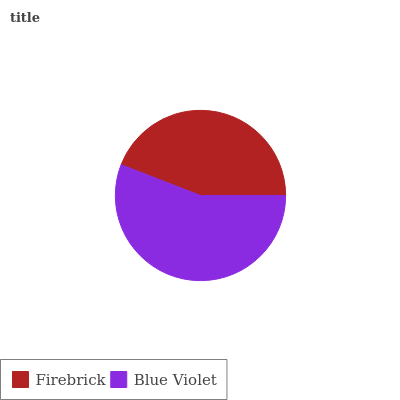Is Firebrick the minimum?
Answer yes or no. Yes. Is Blue Violet the maximum?
Answer yes or no. Yes. Is Blue Violet the minimum?
Answer yes or no. No. Is Blue Violet greater than Firebrick?
Answer yes or no. Yes. Is Firebrick less than Blue Violet?
Answer yes or no. Yes. Is Firebrick greater than Blue Violet?
Answer yes or no. No. Is Blue Violet less than Firebrick?
Answer yes or no. No. Is Blue Violet the high median?
Answer yes or no. Yes. Is Firebrick the low median?
Answer yes or no. Yes. Is Firebrick the high median?
Answer yes or no. No. Is Blue Violet the low median?
Answer yes or no. No. 